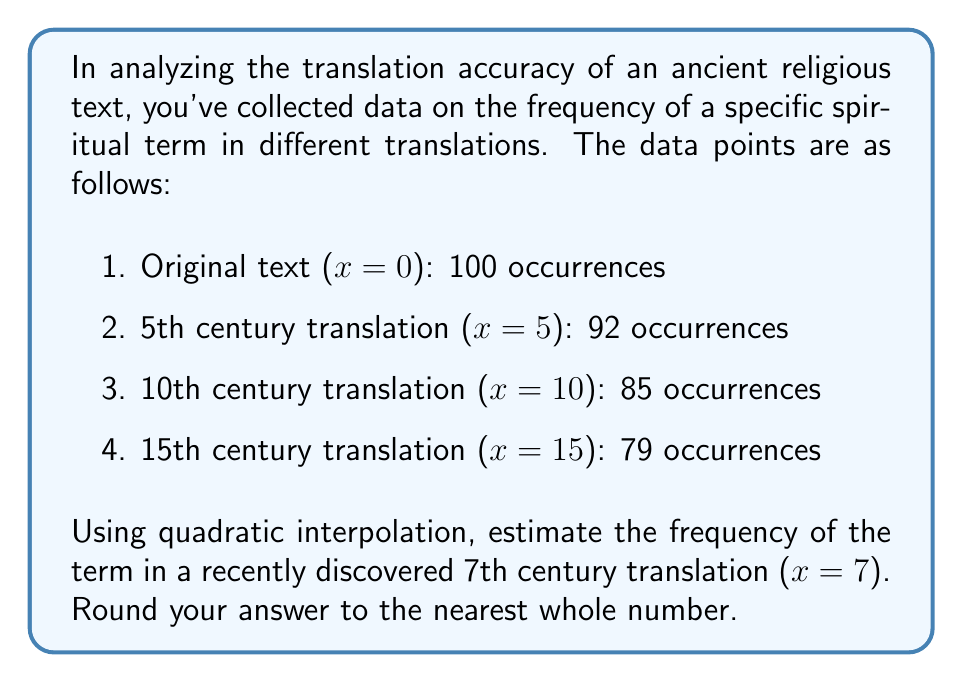Give your solution to this math problem. To solve this problem, we'll use quadratic interpolation with Lagrange polynomials. The steps are as follows:

1) First, we'll select three data points to use for our quadratic interpolation. Let's choose:
   $(x_0, y_0) = (0, 100)$, $(x_1, y_1) = (5, 92)$, and $(x_2, y_2) = (10, 85)$

2) The Lagrange interpolation formula for a quadratic polynomial is:

   $$P(x) = y_0L_0(x) + y_1L_1(x) + y_2L_2(x)$$

   where

   $$L_0(x) = \frac{(x-x_1)(x-x_2)}{(x_0-x_1)(x_0-x_2)}$$
   $$L_1(x) = \frac{(x-x_0)(x-x_2)}{(x_1-x_0)(x_1-x_2)}$$
   $$L_2(x) = \frac{(x-x_0)(x-x_1)}{(x_2-x_0)(x_2-x_1)}$$

3) Let's calculate each $L_i(7)$:

   $$L_0(7) = \frac{(7-5)(7-10)}{(0-5)(0-10)} = \frac{2(-3)}{(-5)(-10)} = \frac{6}{50} = 0.12$$
   $$L_1(7) = \frac{(7-0)(7-10)}{(5-0)(5-10)} = \frac{7(-3)}{5(-5)} = \frac{21}{25} = 0.84$$
   $$L_2(7) = \frac{(7-0)(7-5)}{(10-0)(10-5)} = \frac{7(2)}{10(5)} = \frac{14}{50} = 0.28$$

4) Now we can calculate $P(7)$:

   $$P(7) = 100(0.12) + 92(0.84) + 85(0.28)$$
   $$= 12 + 77.28 + 23.8$$
   $$= 113.08$$

5) Rounding to the nearest whole number:

   $$113.08 \approx 113$$
Answer: 113 